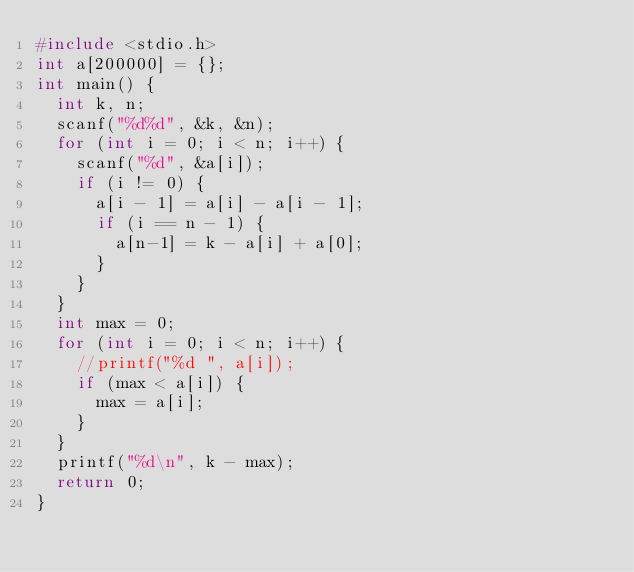<code> <loc_0><loc_0><loc_500><loc_500><_C_>#include <stdio.h>
int a[200000] = {};
int main() {
	int k, n;
	scanf("%d%d", &k, &n);
	for (int i = 0; i < n; i++) {
		scanf("%d", &a[i]);
		if (i != 0) {
			a[i - 1] = a[i] - a[i - 1];
			if (i == n - 1) {
				a[n-1] = k - a[i] + a[0];
			}
		}
	}
	int max = 0;
	for (int i = 0; i < n; i++) {
		//printf("%d ", a[i]);
		if (max < a[i]) {
			max = a[i];
		}
	}
	printf("%d\n", k - max);
	return 0;
}</code> 